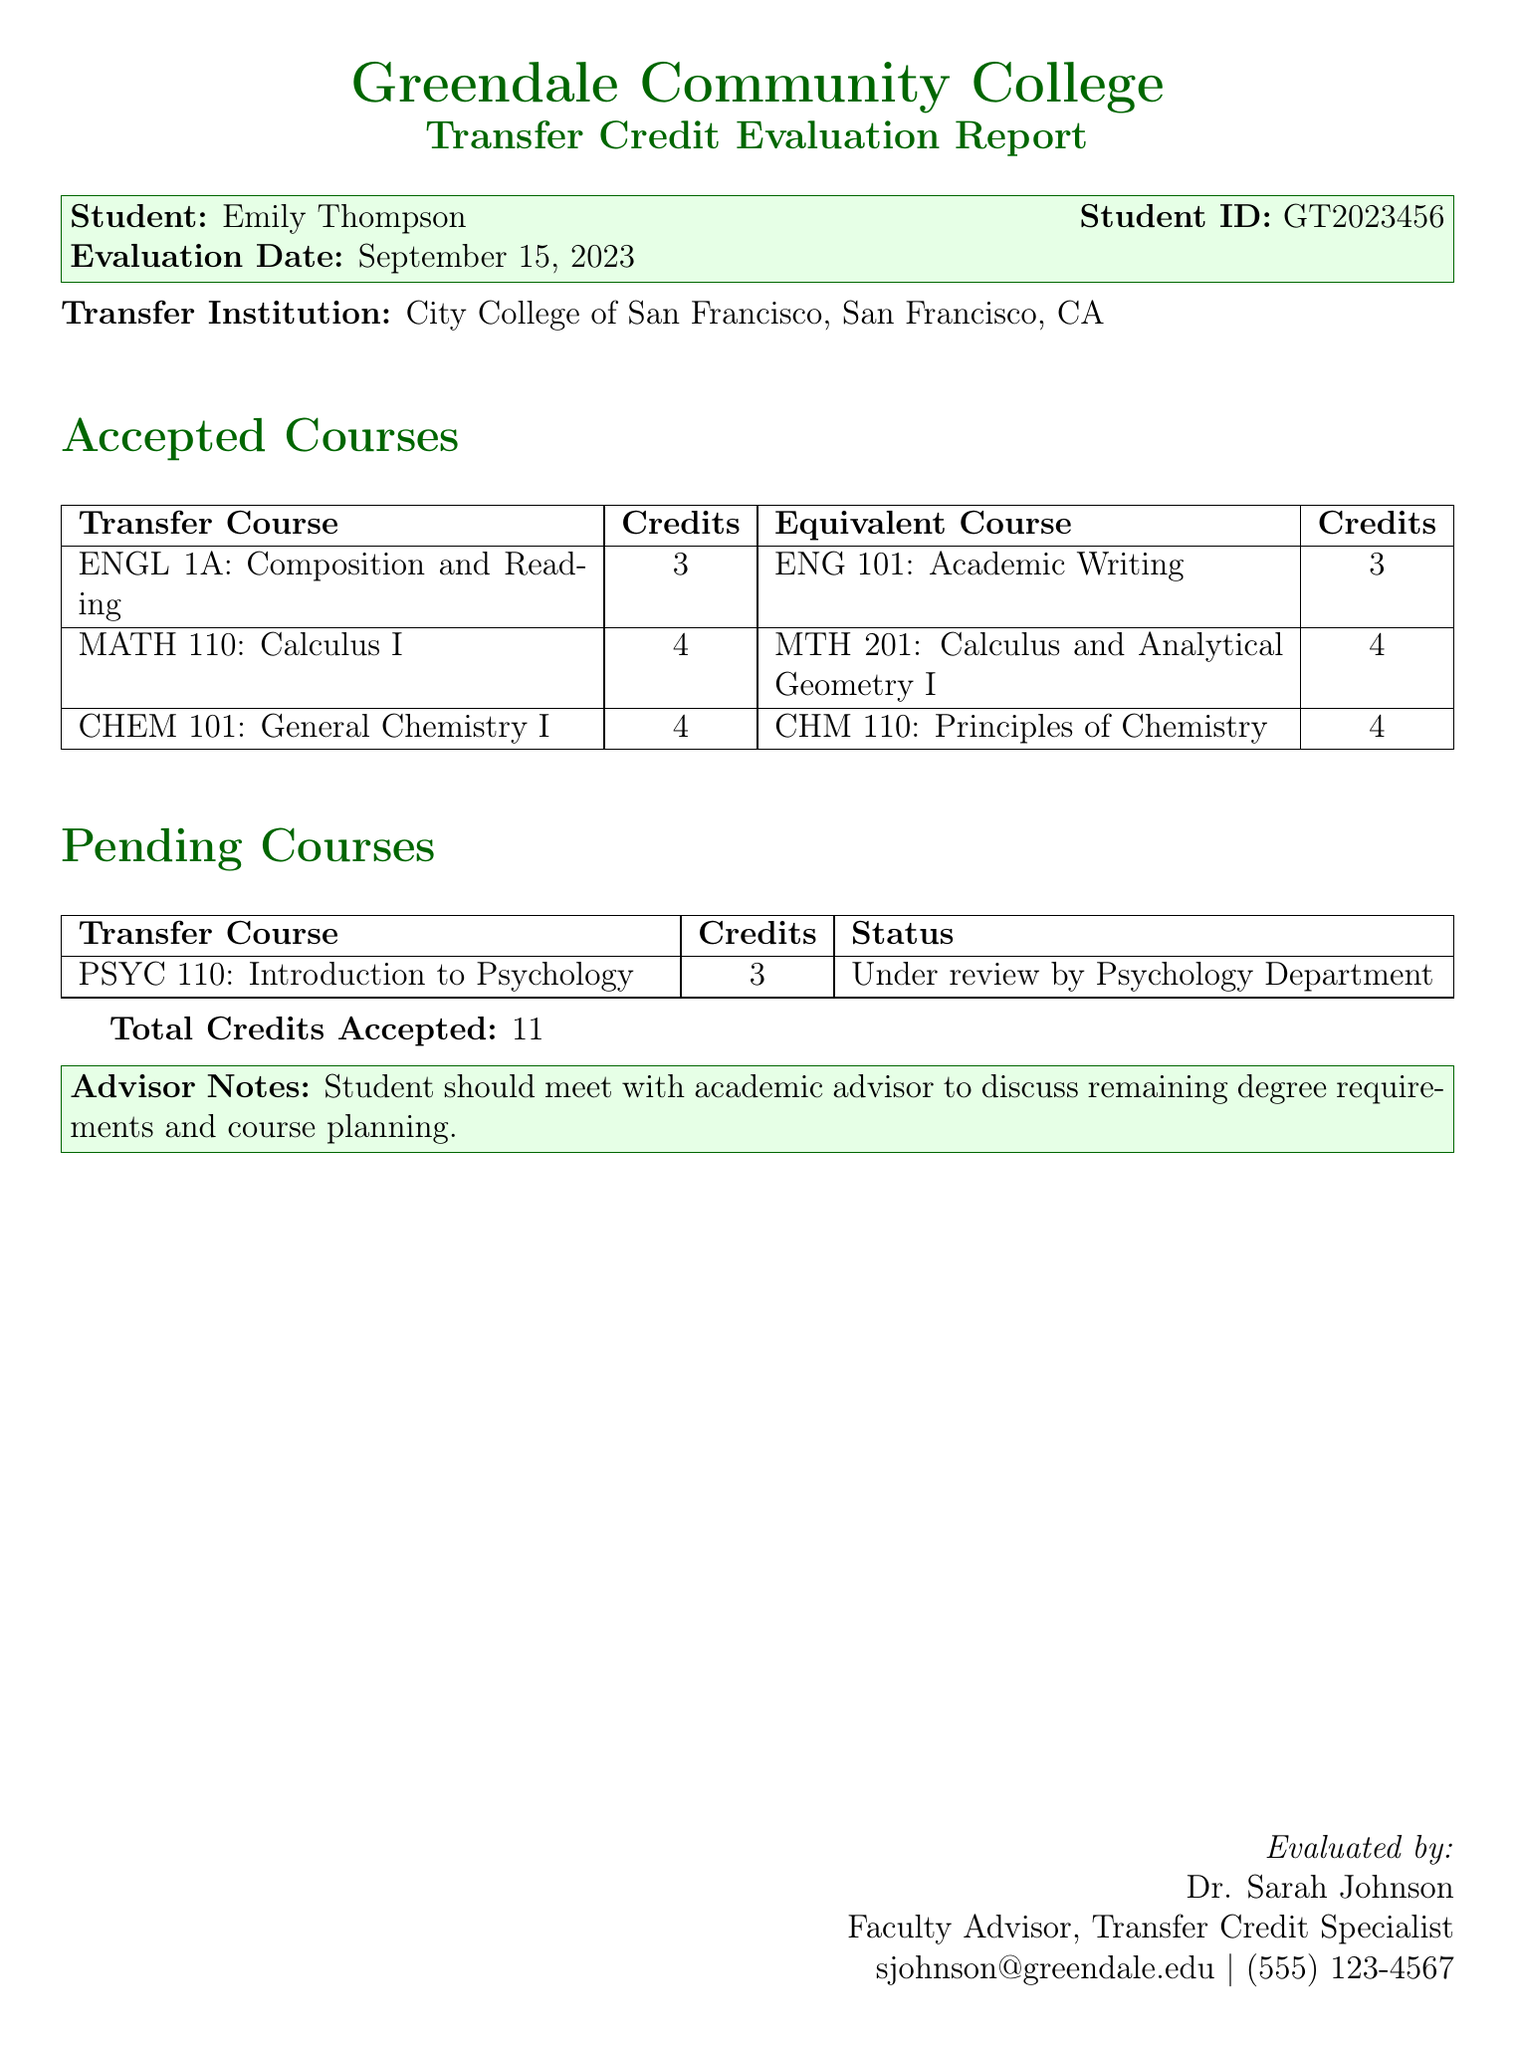What is the student's name? The student's name is clearly stated in the header of the document under the "Student" label.
Answer: Emily Thompson What is the total number of accepted credits? The total credits accepted are summarized at the bottom of the "Accepted Courses" section.
Answer: 11 What is the status of the pending course? The status of the pending course is listed in the "Pending Courses" section of the document.
Answer: Under review by Psychology Department What course is equivalent to ENGL 1A? The equivalent course for ENGL 1A can be found in the "Accepted Courses" table under its corresponding row.
Answer: ENG 101: Academic Writing Who evaluated the report? The evaluators' name and position are provided in the footer of the document.
Answer: Dr. Sarah Johnson What institution is the transfer credit evaluated from? The transfer institution is mentioned prominently in the document, indicating where the courses were taken.
Answer: City College of San Francisco How many credits does CHEM 101 carry? The credits for CHEM 101 are listed in the "Accepted Courses" section alongside its title.
Answer: 4 What course has not yet been evaluated? The pending course is listed under the "Pending Courses" section with its details.
Answer: PSYC 110: Introduction to Psychology 